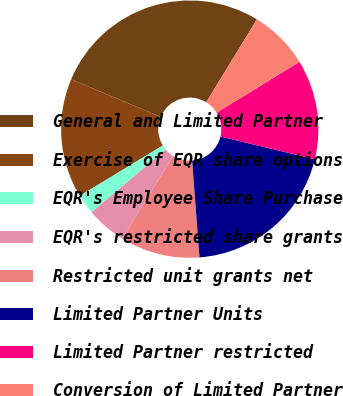Convert chart. <chart><loc_0><loc_0><loc_500><loc_500><pie_chart><fcel>General and Limited Partner<fcel>Exercise of EQR share options<fcel>EQR's Employee Share Purchase<fcel>EQR's restricted share grants<fcel>Restricted unit grants net<fcel>Limited Partner Units<fcel>Limited Partner restricted<fcel>Conversion of Limited Partner<nl><fcel>27.4%<fcel>15.02%<fcel>2.5%<fcel>5.01%<fcel>10.01%<fcel>20.03%<fcel>12.52%<fcel>7.51%<nl></chart> 